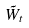Convert formula to latex. <formula><loc_0><loc_0><loc_500><loc_500>\tilde { W } _ { t }</formula> 